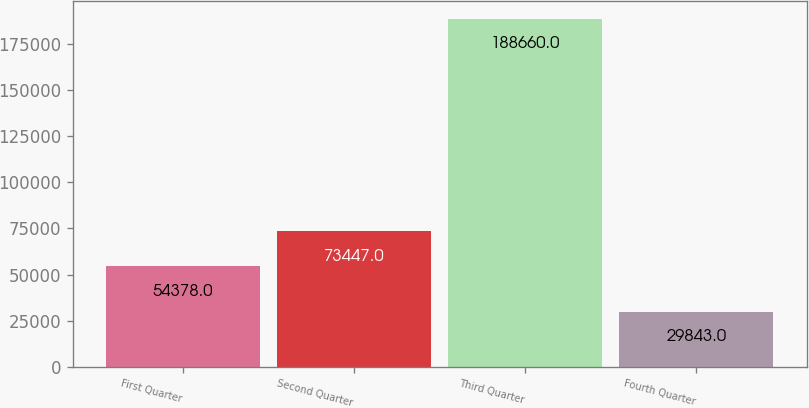Convert chart to OTSL. <chart><loc_0><loc_0><loc_500><loc_500><bar_chart><fcel>First Quarter<fcel>Second Quarter<fcel>Third Quarter<fcel>Fourth Quarter<nl><fcel>54378<fcel>73447<fcel>188660<fcel>29843<nl></chart> 